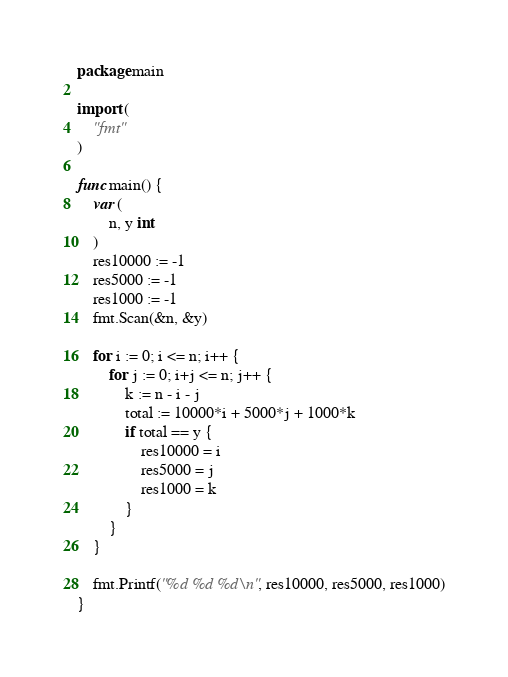<code> <loc_0><loc_0><loc_500><loc_500><_Go_>package main

import (
	"fmt"
)

func main() {
	var (
		n, y int
	)
	res10000 := -1
	res5000 := -1
	res1000 := -1
	fmt.Scan(&n, &y)

	for i := 0; i <= n; i++ {
		for j := 0; i+j <= n; j++ {
			k := n - i - j
			total := 10000*i + 5000*j + 1000*k
			if total == y {
				res10000 = i
				res5000 = j
				res1000 = k
			}
		}
	}

	fmt.Printf("%d %d %d\n", res10000, res5000, res1000)
}
</code> 